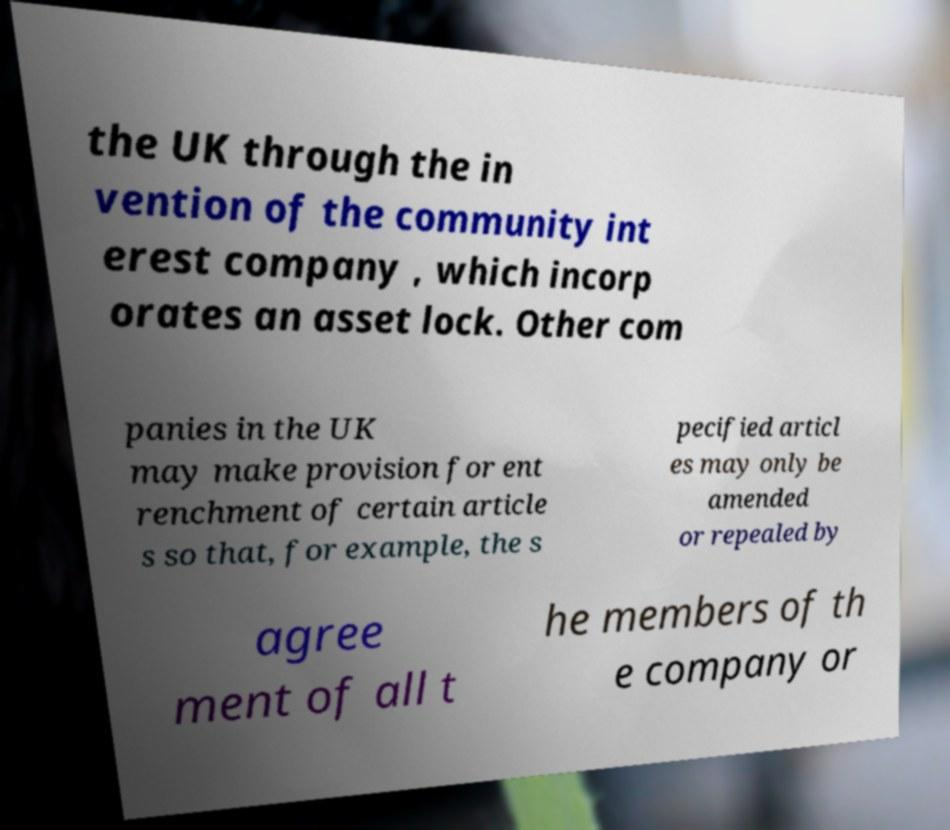Can you accurately transcribe the text from the provided image for me? the UK through the in vention of the community int erest company , which incorp orates an asset lock. Other com panies in the UK may make provision for ent renchment of certain article s so that, for example, the s pecified articl es may only be amended or repealed by agree ment of all t he members of th e company or 